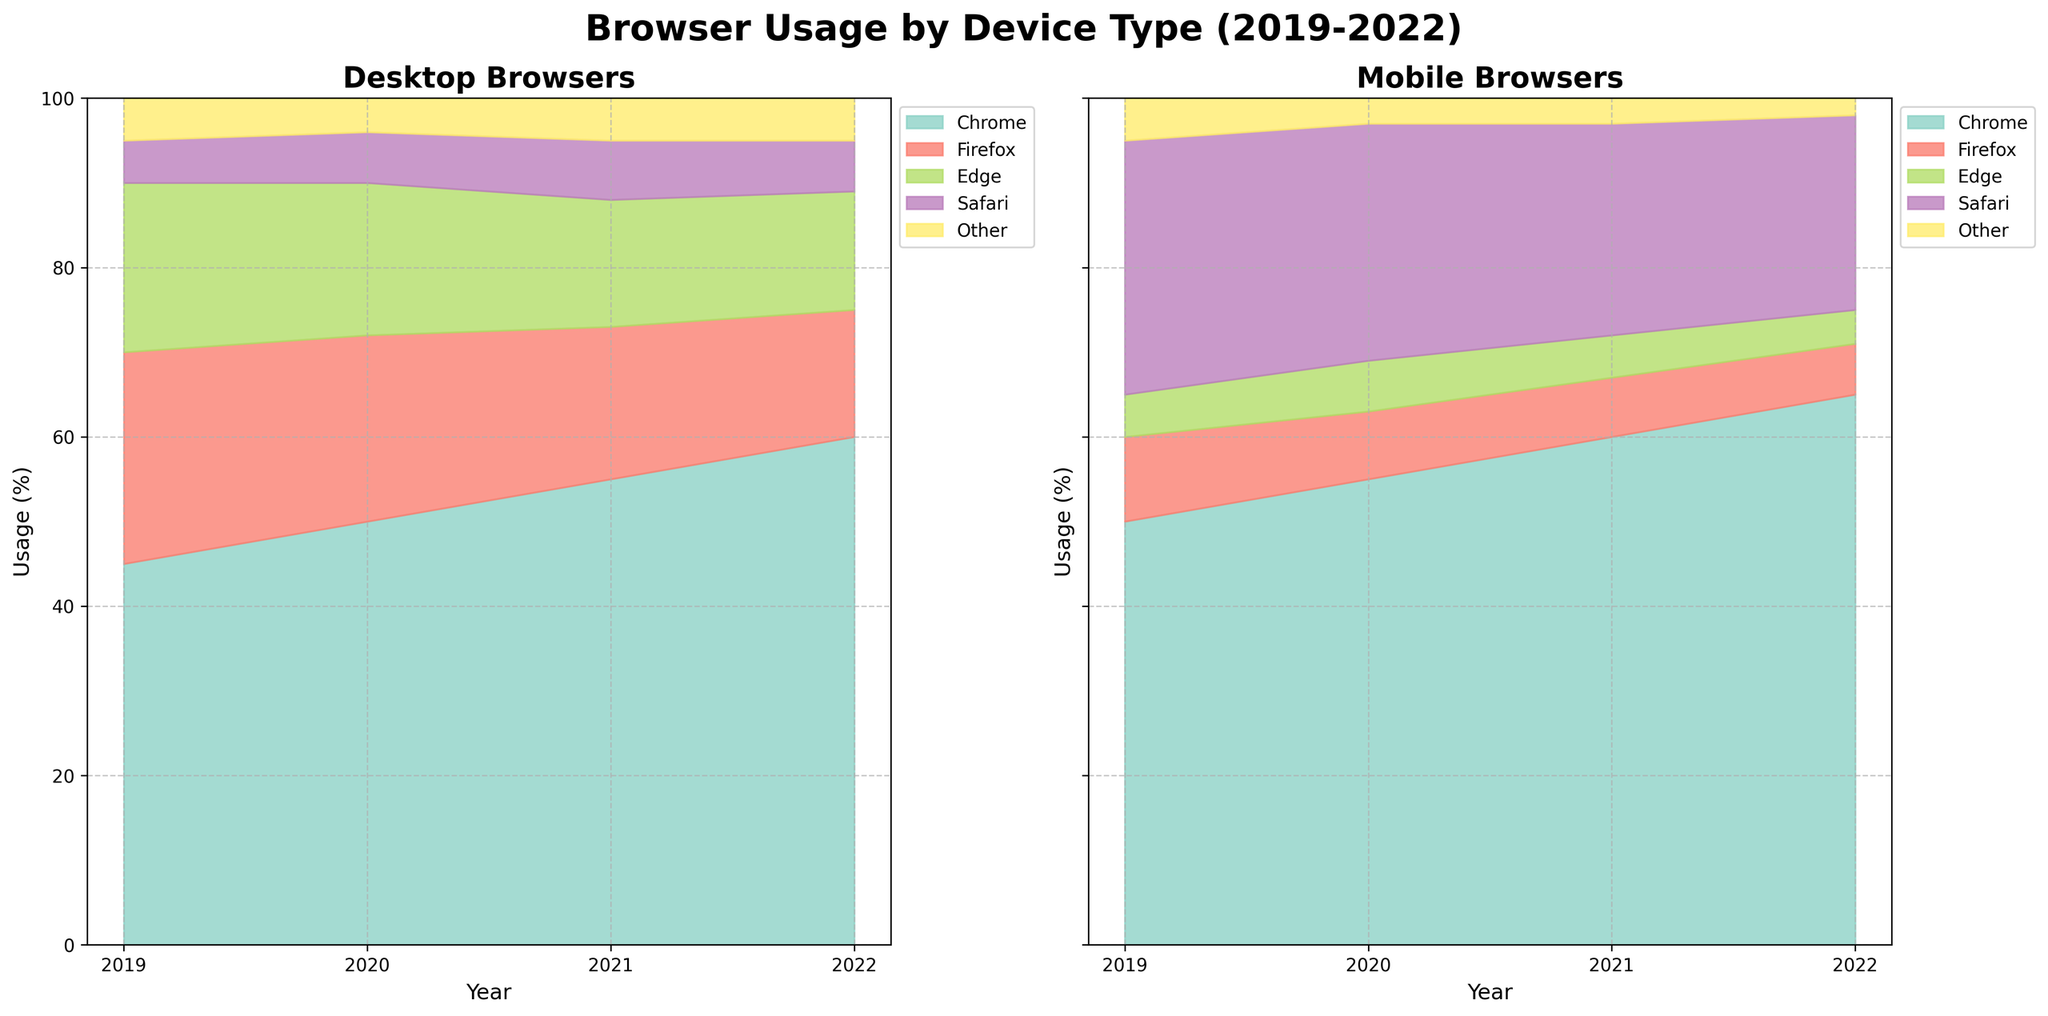What's the title of the figure? The title of the figure is displayed at the top of the plot. It provides a summary of what the figure represents.
Answer: Browser Usage by Device Type (2019-2022) How many years are displayed in the figure? The x-axis represents the years, and counting the labeled points will give the number of years displayed.
Answer: 4 Which browser has the highest usage on desktops in 2019? Look at the respective area chart for desktops in 2019. The area with the largest segment at 2019 represents the browser with the highest usage.
Answer: Chrome Between which two years did desktop Chrome usage increase the most? Compare the heights of the Chrome sections on desktops between consecutive years, the biggest increase is the one we're looking for.
Answer: 2019 to 2020 Which mobile browser had the smallest usage in 2021? Check the respective area chart for mobiles in 2021. The smallest area segment represents the browser with the smallest usage.
Answer: Other What is the approximate total usage of Firefox across all years on desktops? Sum the heights of all Firefox segments over all the years on the desktop chart.
Answer: 25+22+18+15 = 80 How does the browser usage trend for Safari on mobiles change from 2019 to 2022? Observe the height of the Safari segments for mobiles across the years plotted, noting whether they increase, decrease, or stay constant.
Answer: Decreases Which device type shows a more significant decline in Firefox usage from 2019 to 2022? Compare the decline of Firefox usage across the years for both desktops and mobiles, then determine which has the larger drop.
Answer: Desktop What's the combined usage percentage of the "Other" browser category in 2020 for both devices? Add the usage of "Other" from both desktop and mobile categories in the year 2020.
Answer: 4+3 = 7 